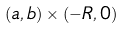<formula> <loc_0><loc_0><loc_500><loc_500>( a , b ) \times ( - R , 0 )</formula> 